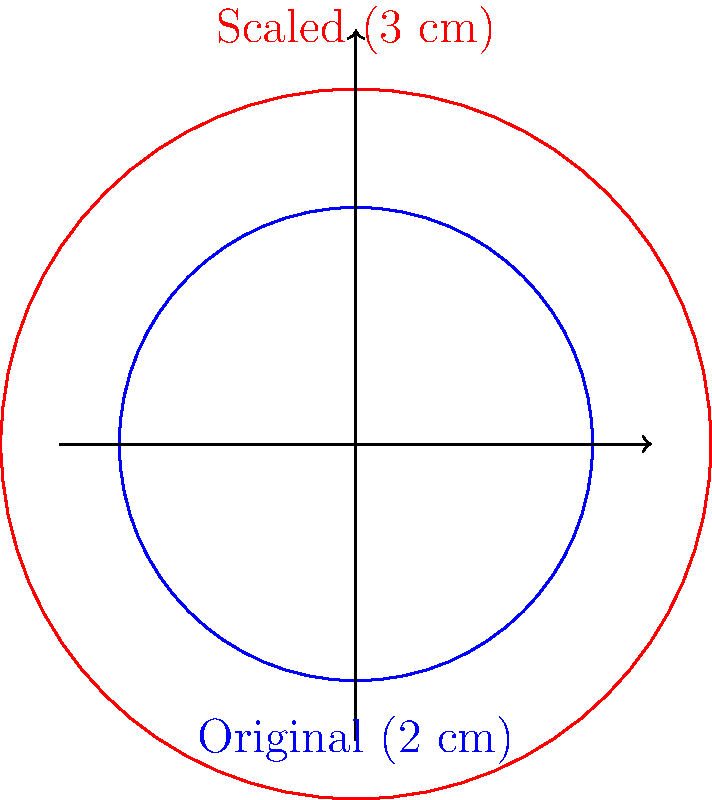You want to resize a circular stencil design from 2 cm in diameter to 3 cm in diameter while maintaining its proportions. What is the scaling factor you should use? To find the scaling factor, we need to follow these steps:

1. Identify the original size: 2 cm diameter
2. Identify the desired size: 3 cm diameter
3. Calculate the scaling factor using the formula:

   $$ \text{Scaling factor} = \frac{\text{New size}}{\text{Original size}} $$

4. Plug in the values:

   $$ \text{Scaling factor} = \frac{3 \text{ cm}}{2 \text{ cm}} $$

5. Simplify the fraction:

   $$ \text{Scaling factor} = \frac{3}{2} = 1.5 $$

Therefore, to resize the stencil from 2 cm to 3 cm in diameter while maintaining proportions, you should use a scaling factor of 1.5 or 150%.
Answer: 1.5 